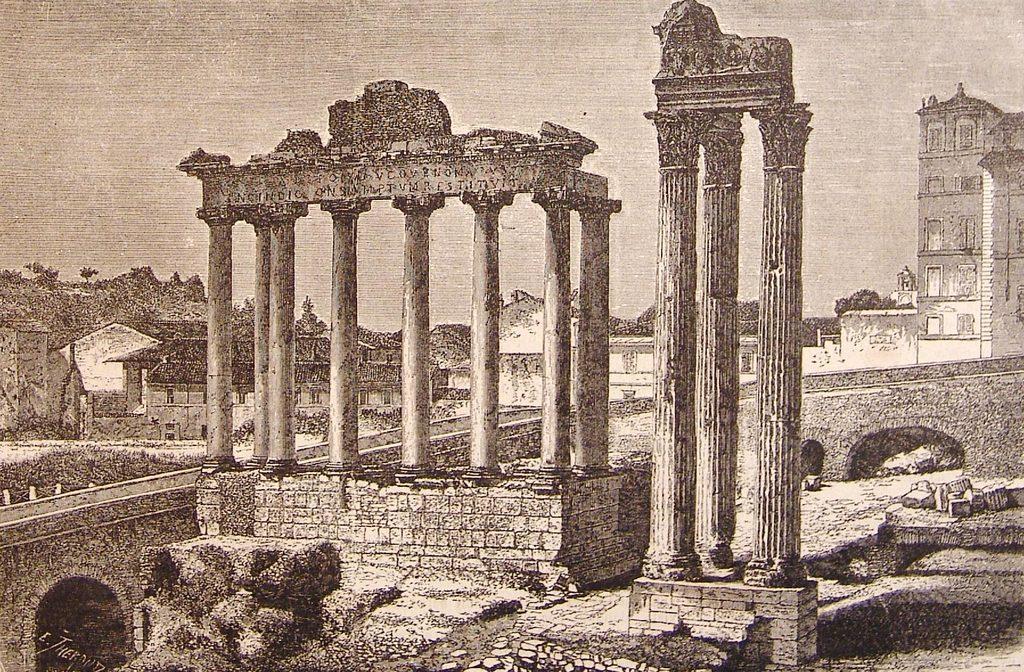Describe this image in one or two sentences. This image is a photo of a monuments and buildings. There is a bridge. 